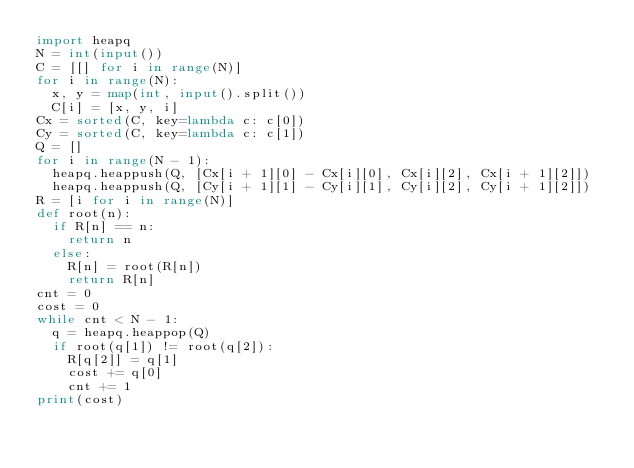Convert code to text. <code><loc_0><loc_0><loc_500><loc_500><_Python_>import heapq
N = int(input())
C = [[] for i in range(N)]
for i in range(N):
  x, y = map(int, input().split())
  C[i] = [x, y, i]
Cx = sorted(C, key=lambda c: c[0])
Cy = sorted(C, key=lambda c: c[1])
Q = []
for i in range(N - 1):
  heapq.heappush(Q, [Cx[i + 1][0] - Cx[i][0], Cx[i][2], Cx[i + 1][2]])
  heapq.heappush(Q, [Cy[i + 1][1] - Cy[i][1], Cy[i][2], Cy[i + 1][2]])
R = [i for i in range(N)]
def root(n):
  if R[n] == n:
    return n
  else:
    R[n] = root(R[n])
    return R[n]
cnt = 0
cost = 0
while cnt < N - 1:
  q = heapq.heappop(Q)
  if root(q[1]) != root(q[2]):
    R[q[2]] = q[1]
    cost += q[0]
    cnt += 1
print(cost)</code> 